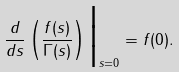Convert formula to latex. <formula><loc_0><loc_0><loc_500><loc_500>\frac { d } { d s } \left ( \frac { f ( s ) } { \Gamma ( s ) } \right ) \Big | _ { s = 0 } = f ( 0 ) .</formula> 